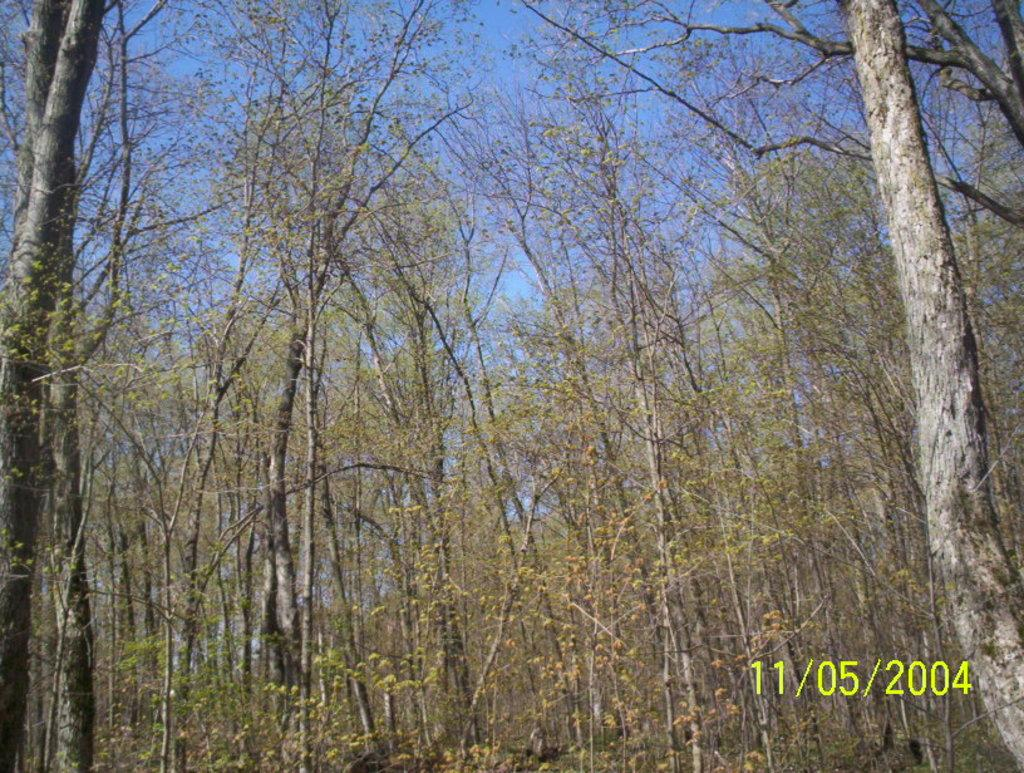What type of vegetation can be seen in the image? There are trees in the image. What part of the natural environment is visible in the image? The sky is visible in the image. What else can be seen in the image besides the trees and sky? There is text present in the image. What type of hat is the society wearing in the image? There is no society or hat present in the image. What is the cause of death depicted in the image? There is no depiction of death in the image. 